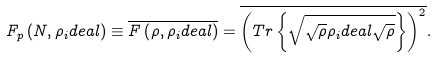<formula> <loc_0><loc_0><loc_500><loc_500>F _ { p } \left ( N , \rho _ { i } d e a l \right ) \equiv \overline { F \left ( \rho , \rho _ { i } d e a l \right ) } = \overline { \left ( T r \left \{ \sqrt { \sqrt { \rho } \rho _ { i } d e a l \sqrt { \rho } } \right \} \right ) ^ { 2 } } .</formula> 